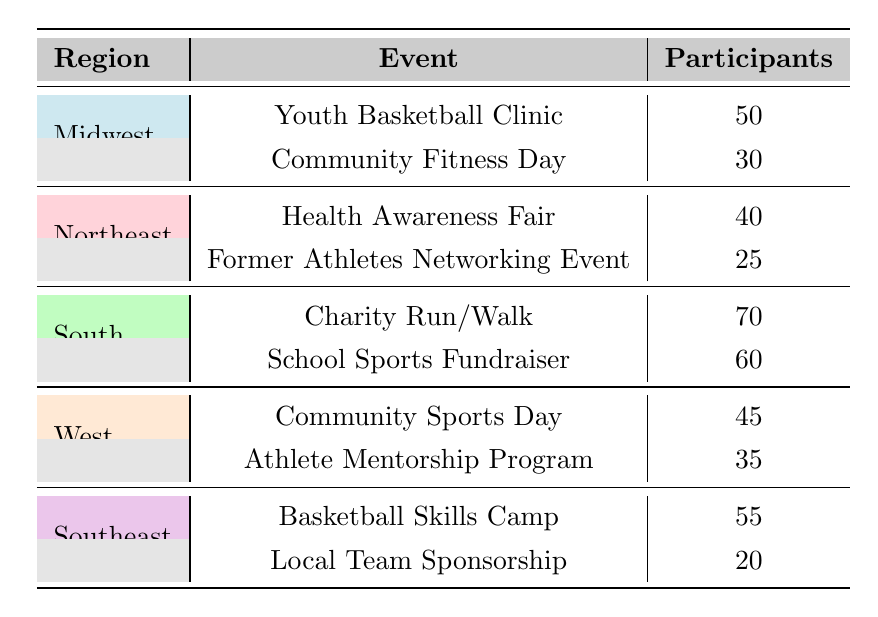What is the total number of participants in community events in the South region? To find the total number of participants in the South region, we need to add the participants of both events in that region: Charity Run/Walk (70) + School Sports Fundraiser (60) = 130.
Answer: 130 Which event in the Midwest had the most participants? In the Midwest region, there are two events: Youth Basketball Clinic (50 participants) and Community Fitness Day (30 participants). The Youth Basketball Clinic has the most participants.
Answer: Youth Basketball Clinic Is the number of participants in the Southeast higher than in the Northeast? For the Southeast, the total participants are Basketball Skills Camp (55) + Local Team Sponsorship (20) = 75. For the Northeast, the total participants are Health Awareness Fair (40) + Former Athletes Networking Event (25) = 65. Since 75 is greater than 65, the statement is true.
Answer: Yes What is the average number of participants per event in the West region? The West region has two events: Community Sports Day (45) and Athlete Mentorship Program (35). We calculate the average by summing the participants (45 + 35 = 80) and dividing by the number of events (2). 80/2 = 40.
Answer: 40 How many participants were in total across all regions? To find the total number of participants across all regions, we add the participants for each event: (50 + 30) + (40 + 25) + (70 + 60) + (45 + 35) + (55 + 20) = 50 + 30 + 40 + 25 + 70 + 60 + 45 + 35 + 55 + 20 =  480.
Answer: 480 Which region had the least number of participants in community events? We can find the total participants for each region: Midwest (80), Northeast (65), South (130), West (80), Southeast (75). The Northeast has the least with 65 participants.
Answer: Northeast Did the Midwest have more participants in total than the West? Total participants in the Midwest are 80, while in the West they are also 80. Since they are equal, the statement is false.
Answer: No What is the difference in participants between the highest and lowest event in the South region? The highest event in the South is Charity Run/Walk with 70 participants, and the lowest is School Sports Fundraiser with 60 participants. The difference is 70 - 60 = 10.
Answer: 10 